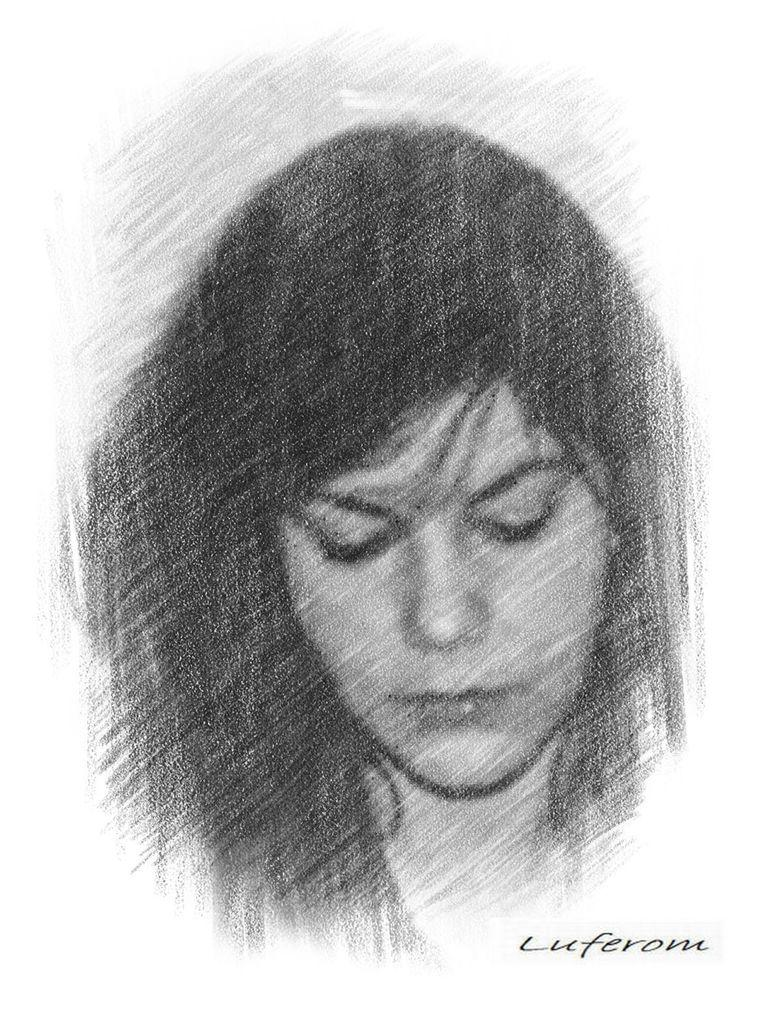What is depicted in the image? There is an art of a person in the image. What color is the art? The art is in black color. Where is the watermark located in the image? The watermark is in the bottom right side of the image. What type of coat is the person wearing in the image? There is no coat visible in the image, as it is an art piece in black color. What is the weather like in the image? The image is an art piece, so it does not depict weather conditions. 